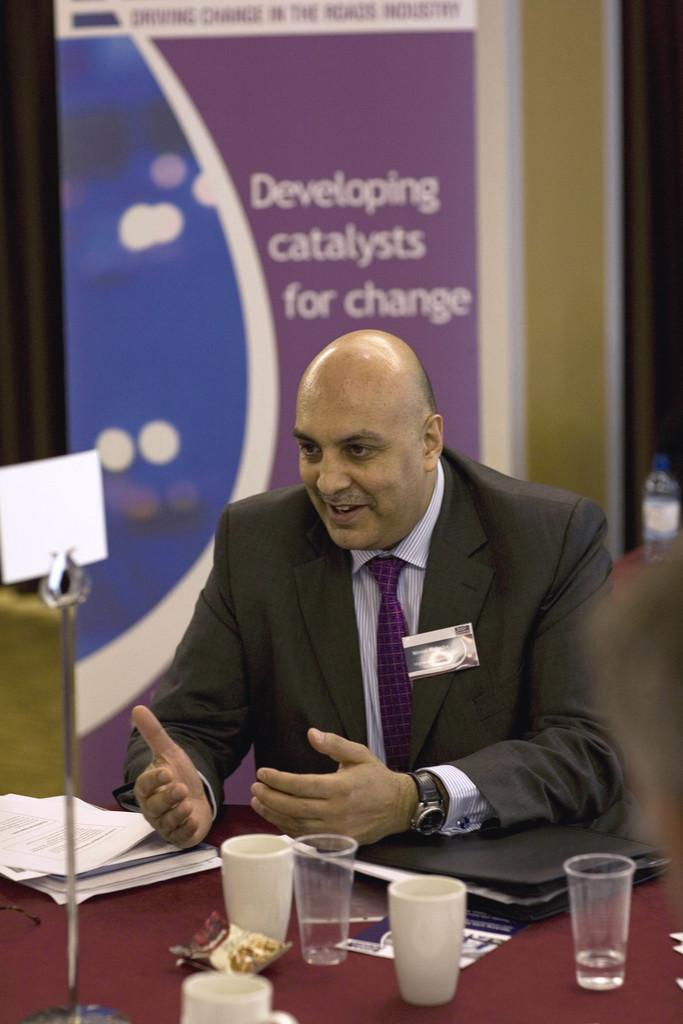What is the man in the image doing? The man is seated and speaking in the image. What is the man sitting on in the image? There is a chair in the image, and the man is seated on it. What objects are on the table in the image? There are glasses and a cup on the table in the image. What type of pear is the monkey eating on the sidewalk in the image? There is no pear, monkey, or sidewalk present in the image. 